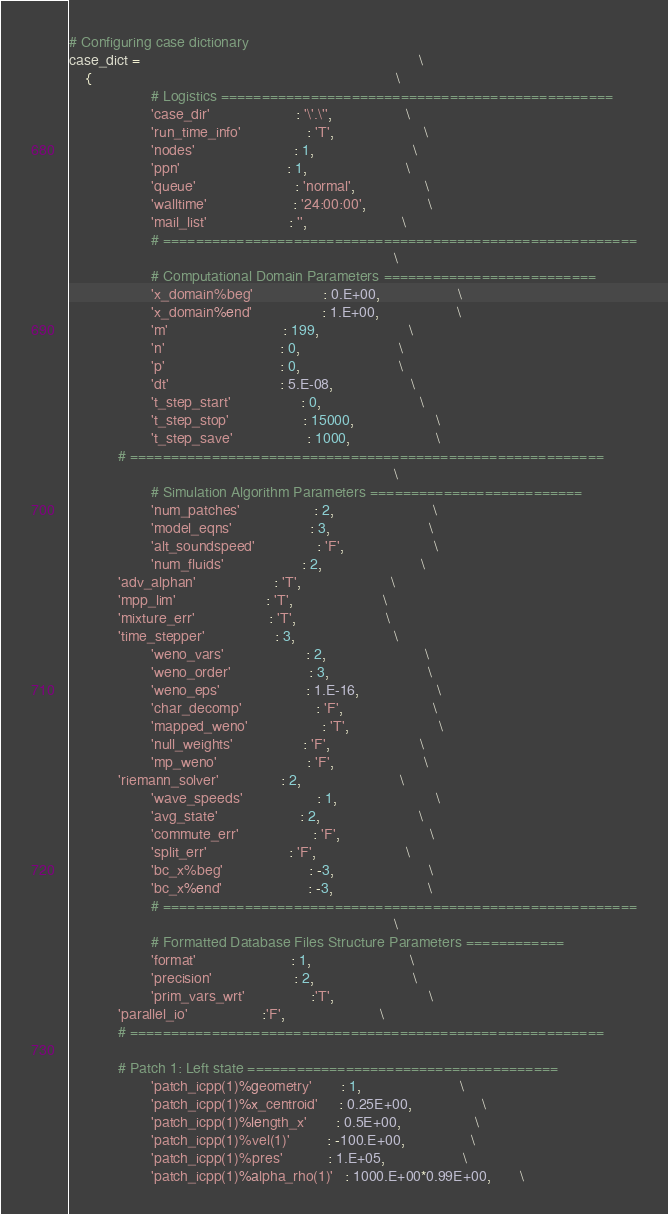Convert code to text. <code><loc_0><loc_0><loc_500><loc_500><_Python_>
# Configuring case dictionary
case_dict =                                                                    \
    {                                                                          \
                    # Logistics ================================================
                    'case_dir'                     : '\'.\'',                  \
                    'run_time_info'                : 'T',                      \
                    'nodes'                        : 1,                        \
                    'ppn'                          : 1,                        \
                    'queue'                        : 'normal',                 \
                    'walltime'                     : '24:00:00',               \
                    'mail_list'                    : '',                       \
                    # ==========================================================
                                                                               \
                    # Computational Domain Parameters ==========================
                    'x_domain%beg'                 : 0.E+00,                   \
                    'x_domain%end'                 : 1.E+00,                   \
                    'm'                            : 199,                      \
                    'n'                            : 0,                        \
                    'p'                            : 0,                        \
                    'dt'                           : 5.E-08,                   \
                    't_step_start'                 : 0,                        \
                    't_step_stop'                  : 15000,                    \
                    't_step_save'                  : 1000,                     \
		    # ==========================================================
                                                                               \
                    # Simulation Algorithm Parameters ==========================
                    'num_patches'                  : 2,                        \
                    'model_eqns'                   : 3,                        \
                    'alt_soundspeed'               : 'F',                      \
                    'num_fluids'                   : 2,                        \
		    'adv_alphan'                   : 'T',                      \
		    'mpp_lim'                      : 'T',                      \
		    'mixture_err'                  : 'T',                      \
		    'time_stepper'                 : 3,                        \
                    'weno_vars'                    : 2,                        \
                    'weno_order'                   : 3,                        \
                    'weno_eps'                     : 1.E-16,                   \
                    'char_decomp'                  : 'F',                      \
                    'mapped_weno'                  : 'T',                      \
                    'null_weights'                 : 'F',                      \
                    'mp_weno'                      : 'F',                      \
		    'riemann_solver'               : 2,                        \
                    'wave_speeds'                  : 1,                        \
                    'avg_state'                    : 2,                        \
                    'commute_err'                  : 'F',                      \
                    'split_err'                    : 'F',                      \
                    'bc_x%beg'                     : -3,                       \
                    'bc_x%end'                     : -3,                       \
                    # ==========================================================
                                                                               \
                    # Formatted Database Files Structure Parameters ============
                    'format'                       : 1,                        \
                    'precision'                    : 2,                        \
                    'prim_vars_wrt'                :'T',                       \
		    'parallel_io'                  :'F',                       \
		    # ==========================================================
                                                                               
		    # Patch 1: Left state ======================================
                    'patch_icpp(1)%geometry'       : 1,                        \
                    'patch_icpp(1)%x_centroid'     : 0.25E+00,                 \
                    'patch_icpp(1)%length_x'       : 0.5E+00,                  \
                    'patch_icpp(1)%vel(1)'         : -100.E+00,                \
                    'patch_icpp(1)%pres'           : 1.E+05,                   \
                    'patch_icpp(1)%alpha_rho(1)'   : 1000.E+00*0.99E+00,       \</code> 